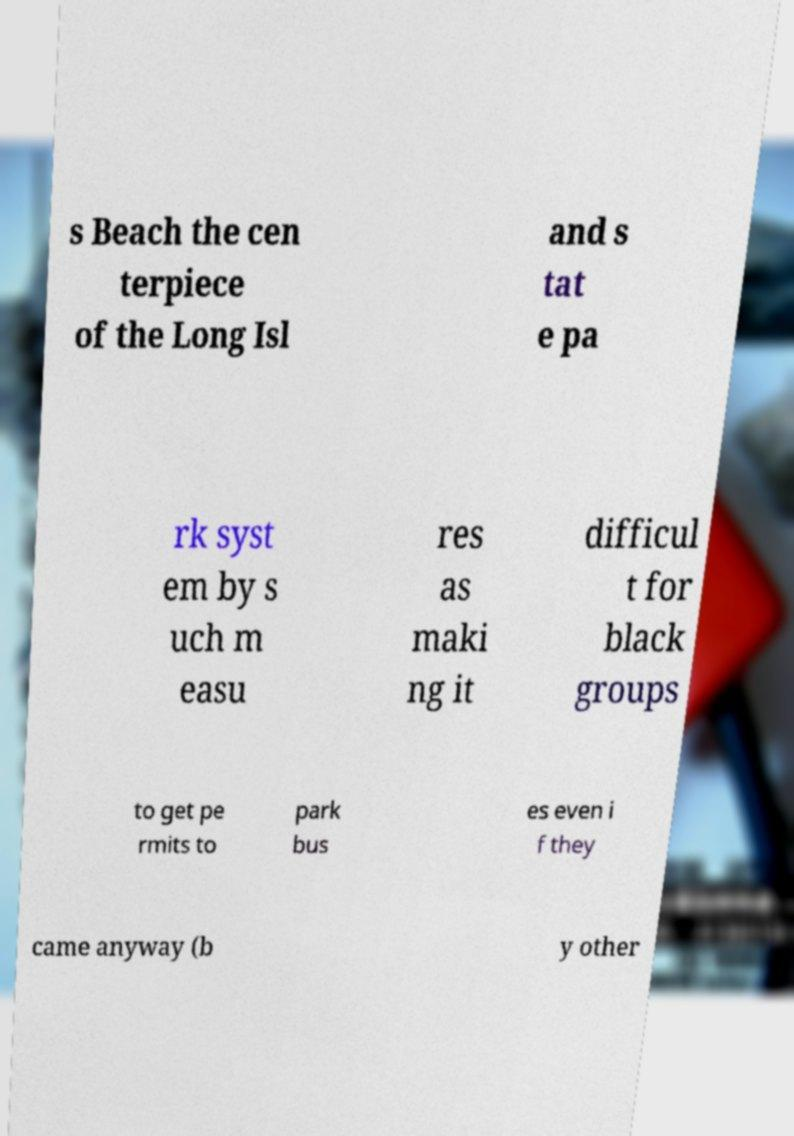Please read and relay the text visible in this image. What does it say? s Beach the cen terpiece of the Long Isl and s tat e pa rk syst em by s uch m easu res as maki ng it difficul t for black groups to get pe rmits to park bus es even i f they came anyway (b y other 